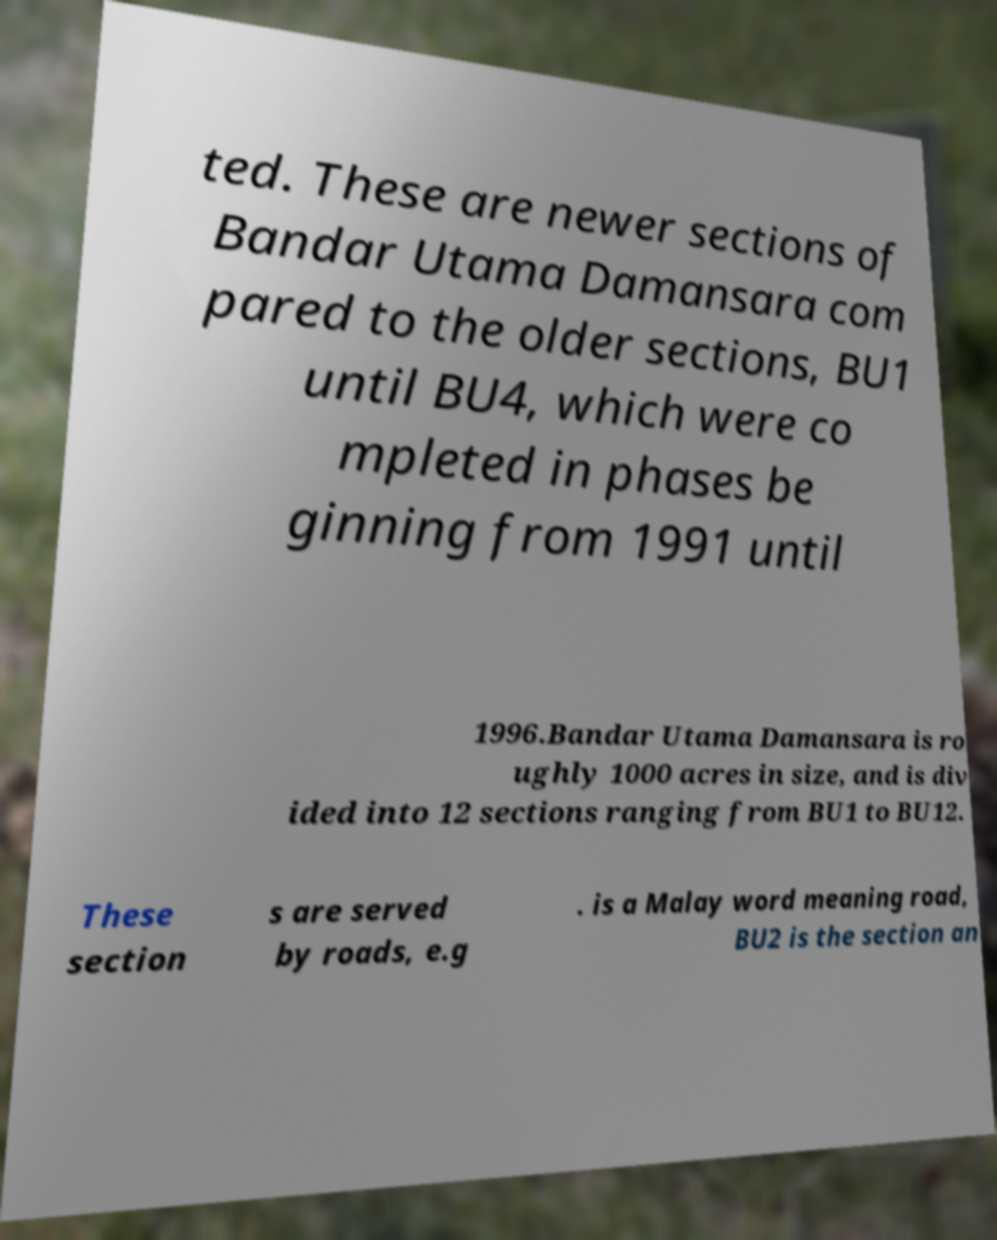Can you read and provide the text displayed in the image?This photo seems to have some interesting text. Can you extract and type it out for me? ted. These are newer sections of Bandar Utama Damansara com pared to the older sections, BU1 until BU4, which were co mpleted in phases be ginning from 1991 until 1996.Bandar Utama Damansara is ro ughly 1000 acres in size, and is div ided into 12 sections ranging from BU1 to BU12. These section s are served by roads, e.g . is a Malay word meaning road, BU2 is the section an 